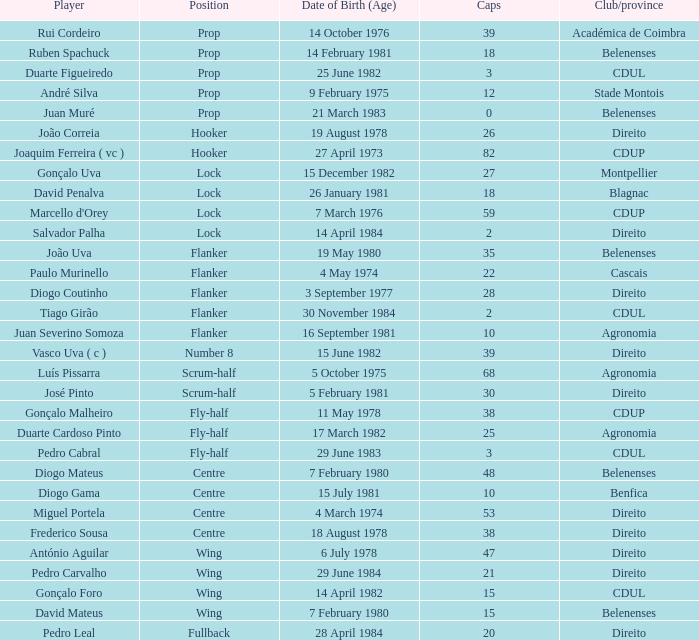Who is the fly-half player with 3 caps? Pedro Cabral. 